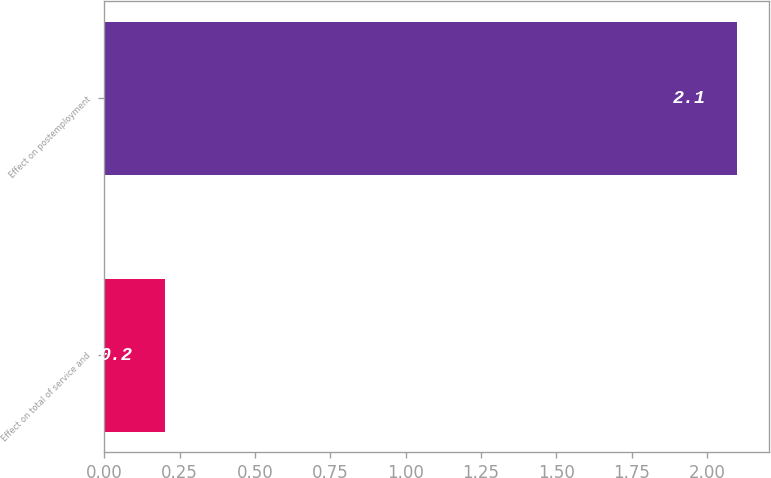Convert chart. <chart><loc_0><loc_0><loc_500><loc_500><bar_chart><fcel>Effect on total of service and<fcel>Effect on postemployment<nl><fcel>0.2<fcel>2.1<nl></chart> 